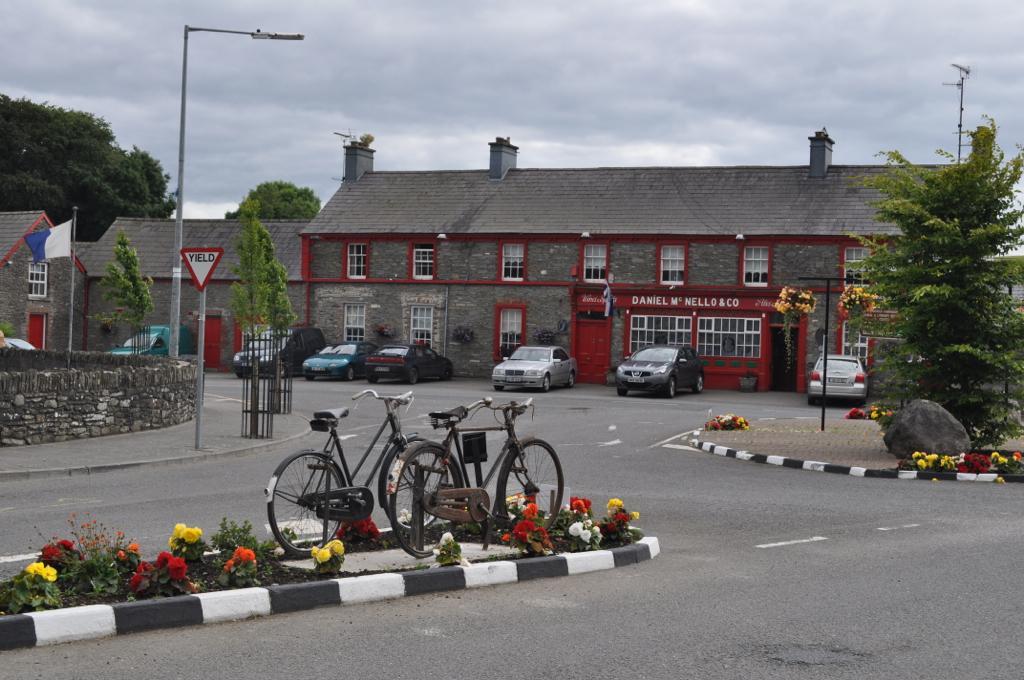Can you describe this image briefly? There are bicycles and flower plants in the foreground area of the image, there are houses, trees, poles, a flag and the sky in the background. 